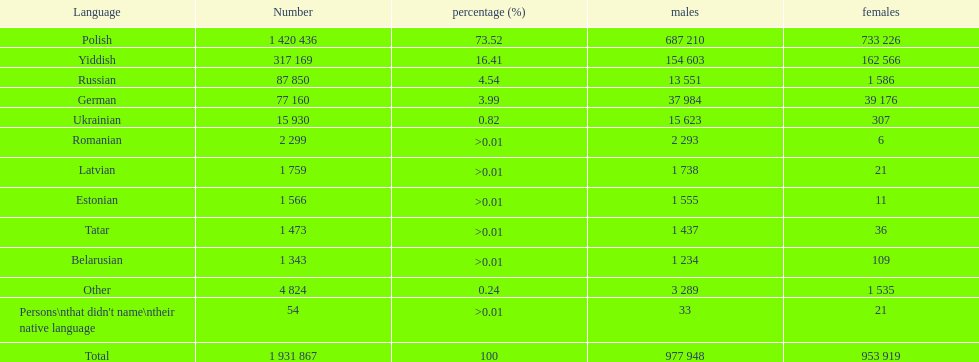What languages are spoken in the warsaw province? Polish, Yiddish, Russian, German, Ukrainian, Romanian, Latvian, Estonian, Tatar, Belarusian, Other, Persons\nthat didn't name\ntheir native language. What is the figure for russian? 87 850. On this list, what is the next smallest figure? 77 160. Which language has a quantity of 77160 speakers? German. Write the full table. {'header': ['Language', 'Number', 'percentage (%)', 'males', 'females'], 'rows': [['Polish', '1 420 436', '73.52', '687 210', '733 226'], ['Yiddish', '317 169', '16.41', '154 603', '162 566'], ['Russian', '87 850', '4.54', '13 551', '1 586'], ['German', '77 160', '3.99', '37 984', '39 176'], ['Ukrainian', '15 930', '0.82', '15 623', '307'], ['Romanian', '2 299', '>0.01', '2 293', '6'], ['Latvian', '1 759', '>0.01', '1 738', '21'], ['Estonian', '1 566', '>0.01', '1 555', '11'], ['Tatar', '1 473', '>0.01', '1 437', '36'], ['Belarusian', '1 343', '>0.01', '1 234', '109'], ['Other', '4 824', '0.24', '3 289', '1 535'], ["Persons\\nthat didn't name\\ntheir native language", '54', '>0.01', '33', '21'], ['Total', '1 931 867', '100', '977 948', '953 919']]} 